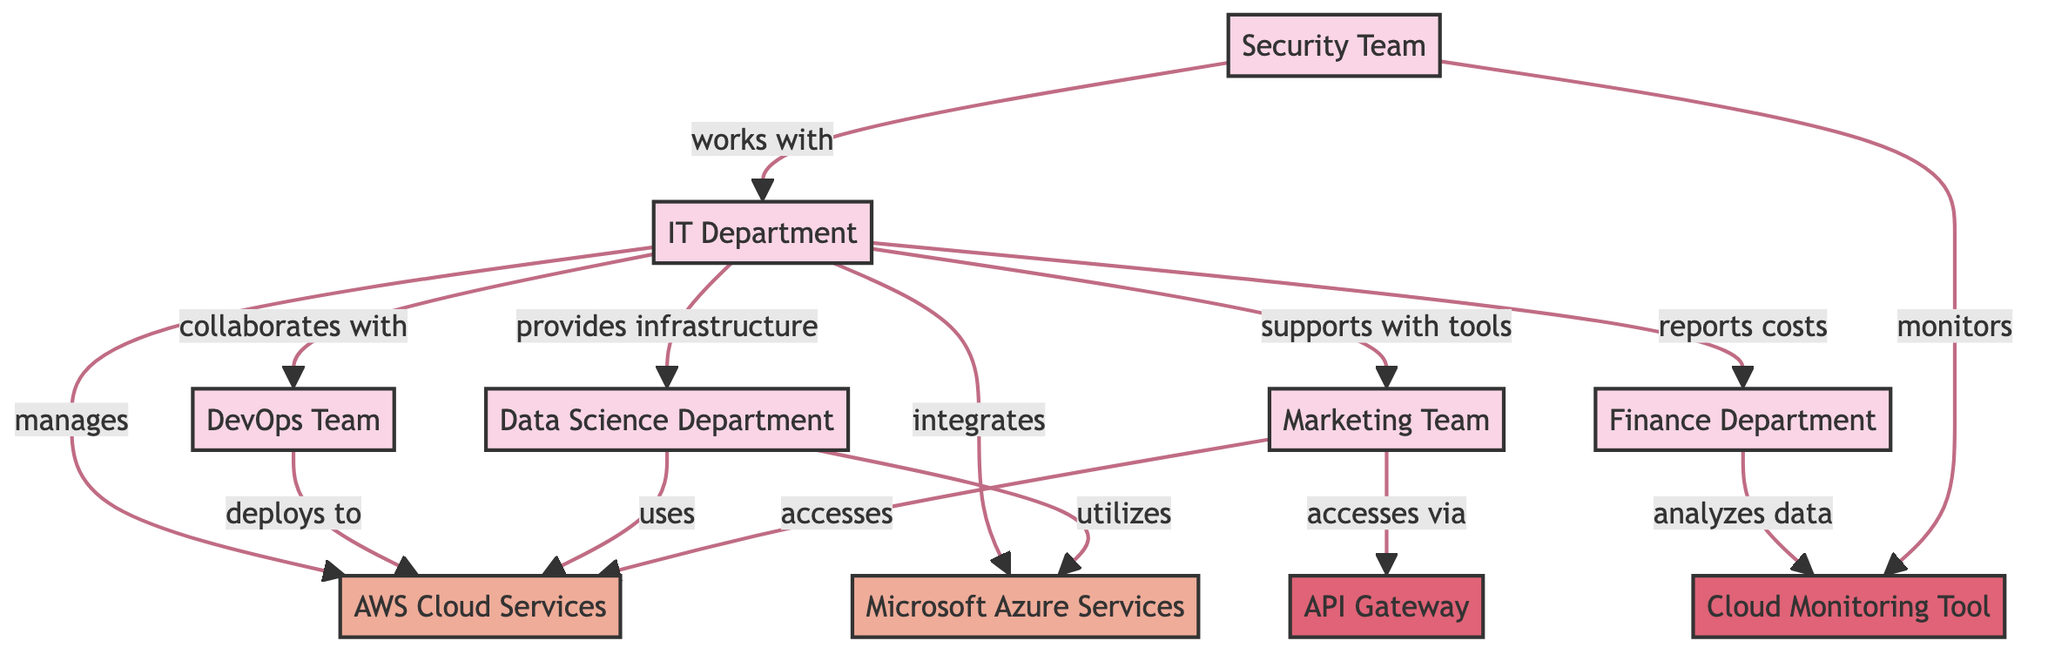What is the relationship between the IT Department and the DevOps Team? The diagram shows that the IT Department collaborates with the DevOps Team. This relationship is indicated by the edge connecting the two nodes, labeled "collaborates with."
Answer: collaborates with How many departments are represented in the diagram? By counting the nodes designated as departments, we find five: IT Department, DevOps Team, Data Science Department, Marketing Team, and Finance Department. Thus, the total is five departments.
Answer: 5 What service does the Data Science Department utilize for data processing? The edge from the Data Science Department to the Microsoft Azure Services node indicates that it utilizes Azure for data processing. The relationship is labeled "utilizes."
Answer: Microsoft Azure Services Which department is responsible for managing and configuring AWS Cloud Services? The edge from the IT Department to the AWS Cloud Services node specifies that the IT Department manages and configures AWS, as signified by the label "manages."
Answer: IT Department Which two teams access AWS Cloud Services in the diagram? We can trace the edges leading from the Marketing Team and Data Science Department to the AWS Cloud Services node. Both teams access this service, indicated by the relationships "accesses" and "uses."
Answer: Marketing Team and Data Science Department How does the Security Team monitor cloud activity? The Security Team monitors alerts from the Cloud Monitoring Tool, as indicated by the edge connecting these two nodes, labeled "monitors." This access allows it to track cloud activity effectively.
Answer: Cloud Monitoring Tool What is the purpose of the API Gateway in the diagram? The edge from the Marketing Team to the API Gateway indicates that it accesses the API Gateway, labeled "accesses via." This signifies that the API Gateway plays a role in managing API requests for the Marketing Team.
Answer: manages API requests What tool does the Finance Department use to analyze cloud usage data? The edge from the Finance Department to the Cloud Monitoring Tool, labeled "analyzes data from," indicates that the Finance Department uses this tool to analyze cloud usage data.
Answer: Cloud Monitoring Tool 